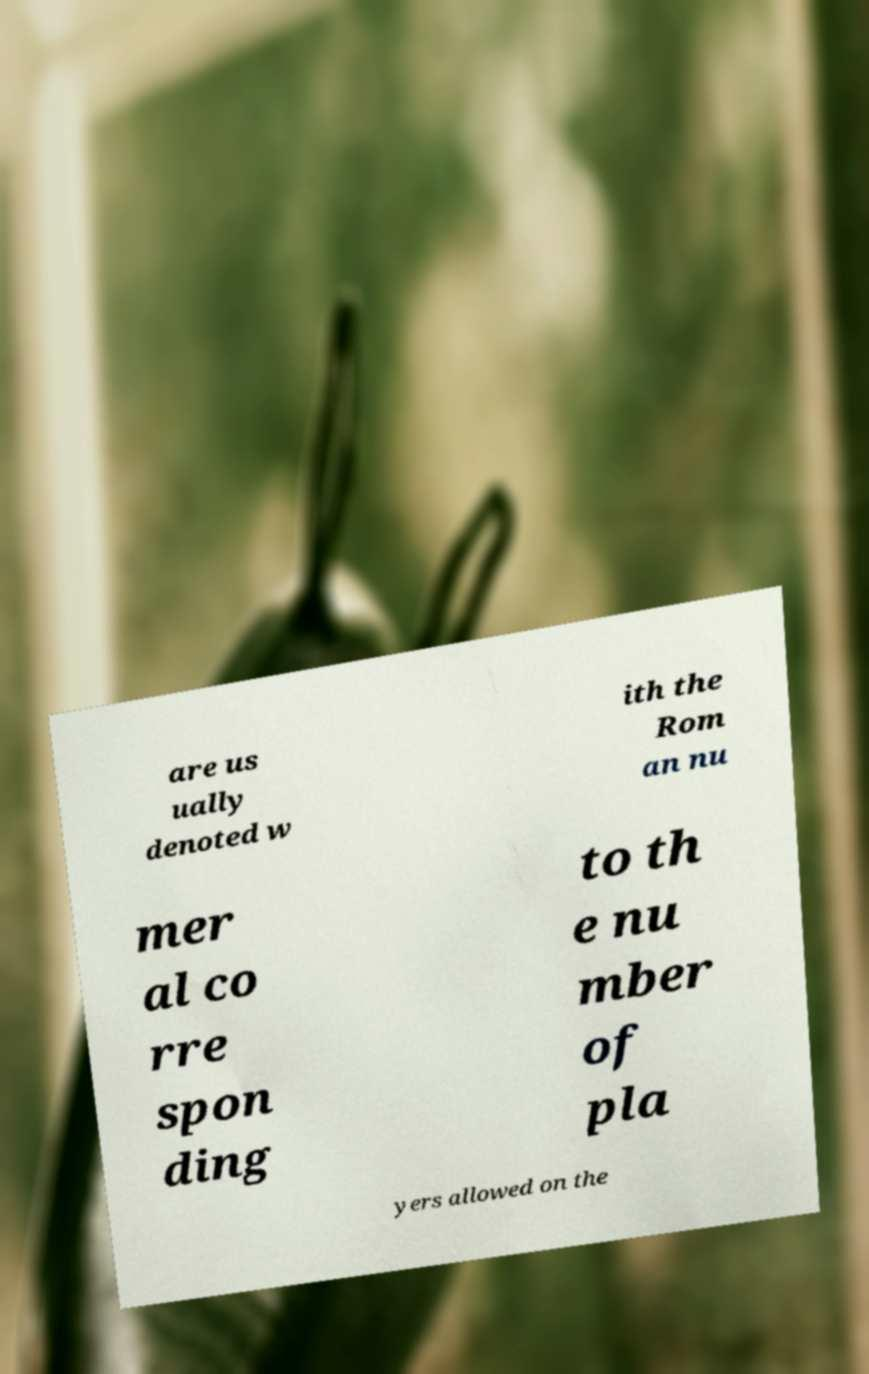Please read and relay the text visible in this image. What does it say? are us ually denoted w ith the Rom an nu mer al co rre spon ding to th e nu mber of pla yers allowed on the 